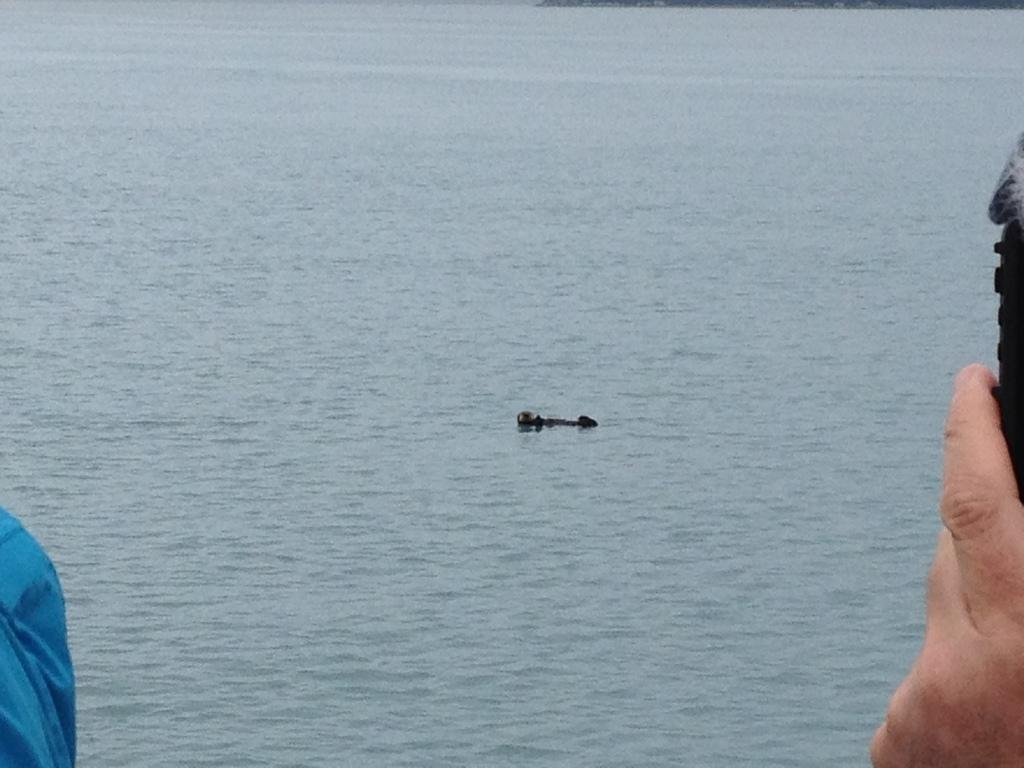What is the hand holding in the image? The hand is holding an object in the image. What is the object floating on water in the image? There is an object floating on water in the image. What type of adjustment can be seen being made to the chair in the image? There is no chair present in the image, so no adjustment can be observed. 